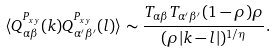<formula> <loc_0><loc_0><loc_500><loc_500>\langle Q _ { \alpha \beta } ^ { P _ { x y } } ( k ) Q _ { \alpha ^ { \prime } \beta ^ { \prime } } ^ { P _ { x y } } ( l ) \rangle \sim \frac { T _ { \alpha \beta } T _ { \alpha ^ { \prime } \beta ^ { \prime } } ( 1 - \rho ) \rho } { ( \rho | k - l | ) ^ { 1 / \eta } } .</formula> 